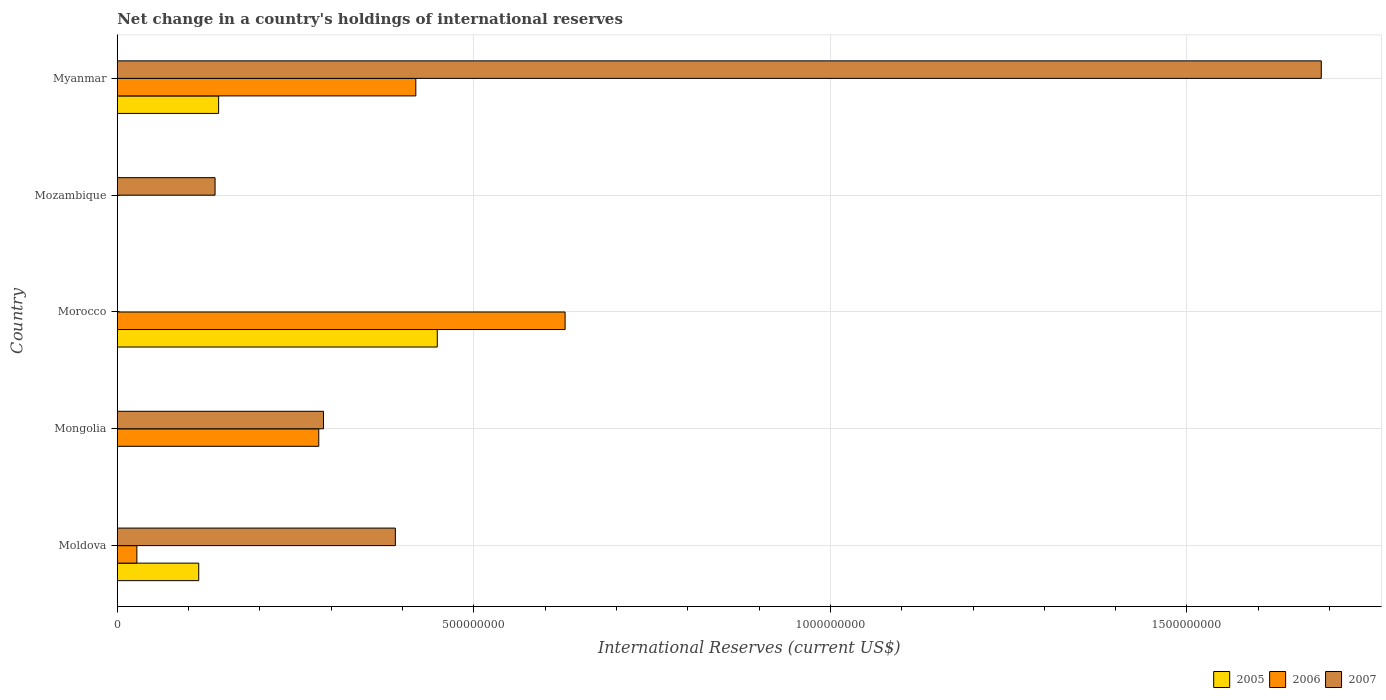How many bars are there on the 4th tick from the bottom?
Your answer should be very brief. 1. What is the label of the 5th group of bars from the top?
Your response must be concise. Moldova. Across all countries, what is the maximum international reserves in 2006?
Provide a succinct answer. 6.28e+08. In which country was the international reserves in 2006 maximum?
Provide a succinct answer. Morocco. What is the total international reserves in 2005 in the graph?
Ensure brevity in your answer.  7.05e+08. What is the difference between the international reserves in 2007 in Mozambique and that in Myanmar?
Give a very brief answer. -1.55e+09. What is the difference between the international reserves in 2006 in Mongolia and the international reserves in 2005 in Mozambique?
Keep it short and to the point. 2.83e+08. What is the average international reserves in 2007 per country?
Offer a terse response. 5.01e+08. What is the difference between the international reserves in 2005 and international reserves in 2006 in Moldova?
Ensure brevity in your answer.  8.67e+07. In how many countries, is the international reserves in 2005 greater than 300000000 US$?
Offer a terse response. 1. What is the ratio of the international reserves in 2005 in Moldova to that in Morocco?
Your response must be concise. 0.25. What is the difference between the highest and the second highest international reserves in 2007?
Make the answer very short. 1.30e+09. What is the difference between the highest and the lowest international reserves in 2007?
Make the answer very short. 1.69e+09. Is the sum of the international reserves in 2007 in Mongolia and Myanmar greater than the maximum international reserves in 2006 across all countries?
Keep it short and to the point. Yes. Are all the bars in the graph horizontal?
Ensure brevity in your answer.  Yes. How many countries are there in the graph?
Your response must be concise. 5. Does the graph contain grids?
Offer a very short reply. Yes. How are the legend labels stacked?
Your answer should be compact. Horizontal. What is the title of the graph?
Your answer should be very brief. Net change in a country's holdings of international reserves. What is the label or title of the X-axis?
Keep it short and to the point. International Reserves (current US$). What is the label or title of the Y-axis?
Provide a short and direct response. Country. What is the International Reserves (current US$) of 2005 in Moldova?
Give a very brief answer. 1.14e+08. What is the International Reserves (current US$) of 2006 in Moldova?
Offer a terse response. 2.75e+07. What is the International Reserves (current US$) in 2007 in Moldova?
Make the answer very short. 3.90e+08. What is the International Reserves (current US$) in 2005 in Mongolia?
Offer a very short reply. 0. What is the International Reserves (current US$) in 2006 in Mongolia?
Make the answer very short. 2.83e+08. What is the International Reserves (current US$) in 2007 in Mongolia?
Your answer should be very brief. 2.89e+08. What is the International Reserves (current US$) in 2005 in Morocco?
Provide a succinct answer. 4.49e+08. What is the International Reserves (current US$) in 2006 in Morocco?
Make the answer very short. 6.28e+08. What is the International Reserves (current US$) of 2006 in Mozambique?
Keep it short and to the point. 0. What is the International Reserves (current US$) of 2007 in Mozambique?
Provide a short and direct response. 1.37e+08. What is the International Reserves (current US$) in 2005 in Myanmar?
Your response must be concise. 1.42e+08. What is the International Reserves (current US$) of 2006 in Myanmar?
Offer a terse response. 4.19e+08. What is the International Reserves (current US$) in 2007 in Myanmar?
Your answer should be compact. 1.69e+09. Across all countries, what is the maximum International Reserves (current US$) in 2005?
Keep it short and to the point. 4.49e+08. Across all countries, what is the maximum International Reserves (current US$) in 2006?
Give a very brief answer. 6.28e+08. Across all countries, what is the maximum International Reserves (current US$) in 2007?
Provide a short and direct response. 1.69e+09. Across all countries, what is the minimum International Reserves (current US$) of 2005?
Make the answer very short. 0. Across all countries, what is the minimum International Reserves (current US$) of 2006?
Make the answer very short. 0. Across all countries, what is the minimum International Reserves (current US$) in 2007?
Your answer should be compact. 0. What is the total International Reserves (current US$) in 2005 in the graph?
Your answer should be very brief. 7.05e+08. What is the total International Reserves (current US$) in 2006 in the graph?
Your response must be concise. 1.36e+09. What is the total International Reserves (current US$) of 2007 in the graph?
Make the answer very short. 2.50e+09. What is the difference between the International Reserves (current US$) of 2006 in Moldova and that in Mongolia?
Keep it short and to the point. -2.55e+08. What is the difference between the International Reserves (current US$) in 2007 in Moldova and that in Mongolia?
Your response must be concise. 1.01e+08. What is the difference between the International Reserves (current US$) in 2005 in Moldova and that in Morocco?
Keep it short and to the point. -3.35e+08. What is the difference between the International Reserves (current US$) in 2006 in Moldova and that in Morocco?
Your answer should be very brief. -6.00e+08. What is the difference between the International Reserves (current US$) of 2007 in Moldova and that in Mozambique?
Make the answer very short. 2.53e+08. What is the difference between the International Reserves (current US$) in 2005 in Moldova and that in Myanmar?
Ensure brevity in your answer.  -2.79e+07. What is the difference between the International Reserves (current US$) in 2006 in Moldova and that in Myanmar?
Offer a terse response. -3.91e+08. What is the difference between the International Reserves (current US$) of 2007 in Moldova and that in Myanmar?
Your answer should be compact. -1.30e+09. What is the difference between the International Reserves (current US$) in 2006 in Mongolia and that in Morocco?
Provide a succinct answer. -3.45e+08. What is the difference between the International Reserves (current US$) in 2007 in Mongolia and that in Mozambique?
Offer a terse response. 1.52e+08. What is the difference between the International Reserves (current US$) in 2006 in Mongolia and that in Myanmar?
Your response must be concise. -1.36e+08. What is the difference between the International Reserves (current US$) of 2007 in Mongolia and that in Myanmar?
Keep it short and to the point. -1.40e+09. What is the difference between the International Reserves (current US$) of 2005 in Morocco and that in Myanmar?
Offer a very short reply. 3.07e+08. What is the difference between the International Reserves (current US$) in 2006 in Morocco and that in Myanmar?
Your answer should be compact. 2.09e+08. What is the difference between the International Reserves (current US$) of 2007 in Mozambique and that in Myanmar?
Your answer should be very brief. -1.55e+09. What is the difference between the International Reserves (current US$) in 2005 in Moldova and the International Reserves (current US$) in 2006 in Mongolia?
Your answer should be compact. -1.68e+08. What is the difference between the International Reserves (current US$) in 2005 in Moldova and the International Reserves (current US$) in 2007 in Mongolia?
Keep it short and to the point. -1.75e+08. What is the difference between the International Reserves (current US$) in 2006 in Moldova and the International Reserves (current US$) in 2007 in Mongolia?
Make the answer very short. -2.62e+08. What is the difference between the International Reserves (current US$) in 2005 in Moldova and the International Reserves (current US$) in 2006 in Morocco?
Your response must be concise. -5.14e+08. What is the difference between the International Reserves (current US$) of 2005 in Moldova and the International Reserves (current US$) of 2007 in Mozambique?
Make the answer very short. -2.29e+07. What is the difference between the International Reserves (current US$) of 2006 in Moldova and the International Reserves (current US$) of 2007 in Mozambique?
Ensure brevity in your answer.  -1.10e+08. What is the difference between the International Reserves (current US$) in 2005 in Moldova and the International Reserves (current US$) in 2006 in Myanmar?
Ensure brevity in your answer.  -3.04e+08. What is the difference between the International Reserves (current US$) of 2005 in Moldova and the International Reserves (current US$) of 2007 in Myanmar?
Offer a very short reply. -1.57e+09. What is the difference between the International Reserves (current US$) in 2006 in Moldova and the International Reserves (current US$) in 2007 in Myanmar?
Your answer should be very brief. -1.66e+09. What is the difference between the International Reserves (current US$) of 2006 in Mongolia and the International Reserves (current US$) of 2007 in Mozambique?
Offer a very short reply. 1.45e+08. What is the difference between the International Reserves (current US$) of 2006 in Mongolia and the International Reserves (current US$) of 2007 in Myanmar?
Ensure brevity in your answer.  -1.41e+09. What is the difference between the International Reserves (current US$) in 2005 in Morocco and the International Reserves (current US$) in 2007 in Mozambique?
Give a very brief answer. 3.12e+08. What is the difference between the International Reserves (current US$) of 2006 in Morocco and the International Reserves (current US$) of 2007 in Mozambique?
Provide a short and direct response. 4.91e+08. What is the difference between the International Reserves (current US$) of 2005 in Morocco and the International Reserves (current US$) of 2006 in Myanmar?
Provide a short and direct response. 3.01e+07. What is the difference between the International Reserves (current US$) in 2005 in Morocco and the International Reserves (current US$) in 2007 in Myanmar?
Ensure brevity in your answer.  -1.24e+09. What is the difference between the International Reserves (current US$) in 2006 in Morocco and the International Reserves (current US$) in 2007 in Myanmar?
Make the answer very short. -1.06e+09. What is the average International Reserves (current US$) of 2005 per country?
Your answer should be very brief. 1.41e+08. What is the average International Reserves (current US$) in 2006 per country?
Offer a terse response. 2.71e+08. What is the average International Reserves (current US$) in 2007 per country?
Offer a very short reply. 5.01e+08. What is the difference between the International Reserves (current US$) in 2005 and International Reserves (current US$) in 2006 in Moldova?
Offer a very short reply. 8.67e+07. What is the difference between the International Reserves (current US$) in 2005 and International Reserves (current US$) in 2007 in Moldova?
Provide a short and direct response. -2.76e+08. What is the difference between the International Reserves (current US$) in 2006 and International Reserves (current US$) in 2007 in Moldova?
Make the answer very short. -3.62e+08. What is the difference between the International Reserves (current US$) of 2006 and International Reserves (current US$) of 2007 in Mongolia?
Provide a succinct answer. -6.62e+06. What is the difference between the International Reserves (current US$) in 2005 and International Reserves (current US$) in 2006 in Morocco?
Ensure brevity in your answer.  -1.79e+08. What is the difference between the International Reserves (current US$) of 2005 and International Reserves (current US$) of 2006 in Myanmar?
Offer a very short reply. -2.77e+08. What is the difference between the International Reserves (current US$) of 2005 and International Reserves (current US$) of 2007 in Myanmar?
Keep it short and to the point. -1.55e+09. What is the difference between the International Reserves (current US$) in 2006 and International Reserves (current US$) in 2007 in Myanmar?
Ensure brevity in your answer.  -1.27e+09. What is the ratio of the International Reserves (current US$) of 2006 in Moldova to that in Mongolia?
Offer a very short reply. 0.1. What is the ratio of the International Reserves (current US$) of 2007 in Moldova to that in Mongolia?
Provide a short and direct response. 1.35. What is the ratio of the International Reserves (current US$) of 2005 in Moldova to that in Morocco?
Your answer should be compact. 0.25. What is the ratio of the International Reserves (current US$) in 2006 in Moldova to that in Morocco?
Provide a succinct answer. 0.04. What is the ratio of the International Reserves (current US$) in 2007 in Moldova to that in Mozambique?
Make the answer very short. 2.84. What is the ratio of the International Reserves (current US$) in 2005 in Moldova to that in Myanmar?
Give a very brief answer. 0.8. What is the ratio of the International Reserves (current US$) of 2006 in Moldova to that in Myanmar?
Make the answer very short. 0.07. What is the ratio of the International Reserves (current US$) of 2007 in Moldova to that in Myanmar?
Offer a terse response. 0.23. What is the ratio of the International Reserves (current US$) in 2006 in Mongolia to that in Morocco?
Your answer should be compact. 0.45. What is the ratio of the International Reserves (current US$) of 2007 in Mongolia to that in Mozambique?
Keep it short and to the point. 2.11. What is the ratio of the International Reserves (current US$) in 2006 in Mongolia to that in Myanmar?
Provide a short and direct response. 0.67. What is the ratio of the International Reserves (current US$) in 2007 in Mongolia to that in Myanmar?
Provide a short and direct response. 0.17. What is the ratio of the International Reserves (current US$) of 2005 in Morocco to that in Myanmar?
Your response must be concise. 3.16. What is the ratio of the International Reserves (current US$) of 2006 in Morocco to that in Myanmar?
Provide a succinct answer. 1.5. What is the ratio of the International Reserves (current US$) of 2007 in Mozambique to that in Myanmar?
Your answer should be very brief. 0.08. What is the difference between the highest and the second highest International Reserves (current US$) in 2005?
Your response must be concise. 3.07e+08. What is the difference between the highest and the second highest International Reserves (current US$) of 2006?
Ensure brevity in your answer.  2.09e+08. What is the difference between the highest and the second highest International Reserves (current US$) of 2007?
Keep it short and to the point. 1.30e+09. What is the difference between the highest and the lowest International Reserves (current US$) in 2005?
Offer a very short reply. 4.49e+08. What is the difference between the highest and the lowest International Reserves (current US$) of 2006?
Make the answer very short. 6.28e+08. What is the difference between the highest and the lowest International Reserves (current US$) in 2007?
Provide a short and direct response. 1.69e+09. 